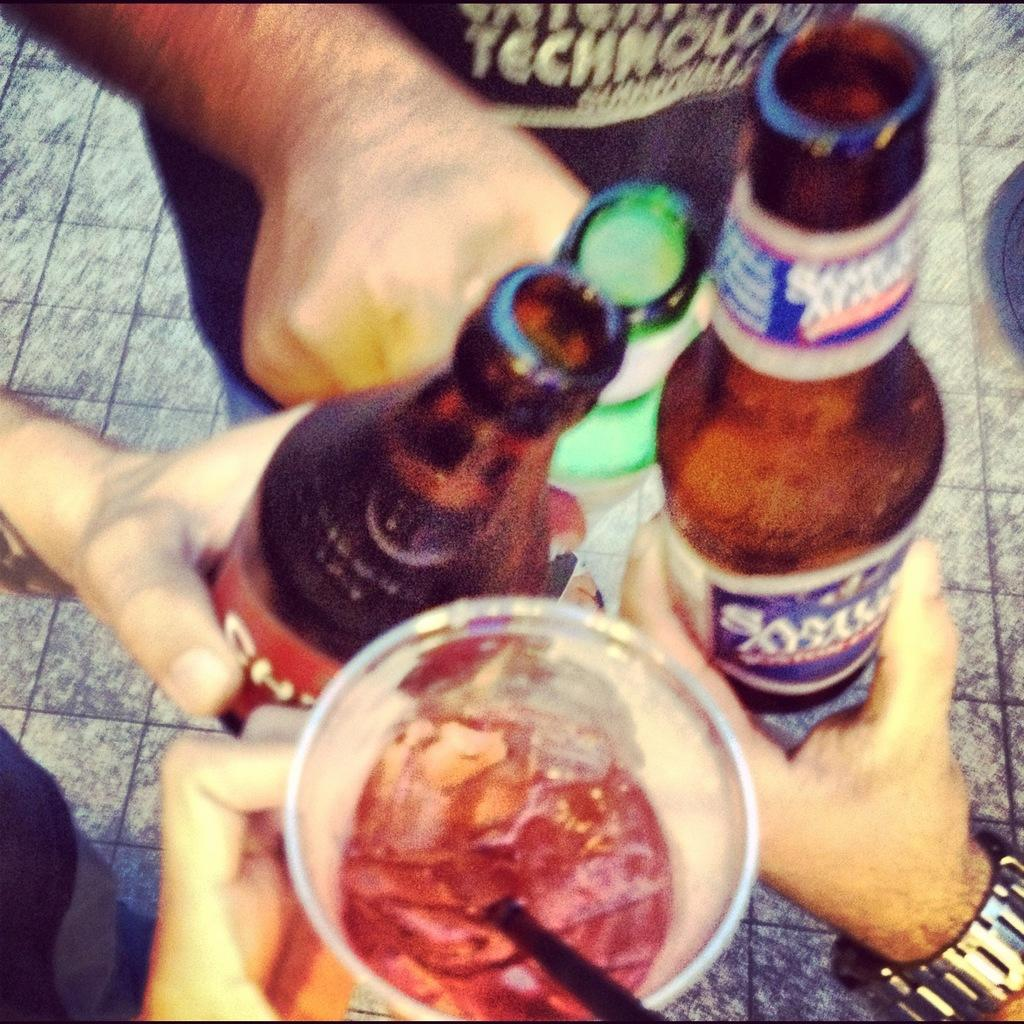How many people are present in the image? There are three people in the image. What are the people holding in the image? The people are holding a bottle. Are there any other bottles visible in the image? Yes, there are bottles in the image. What can be seen in the glass in the image? There is a glass with liquid content in the image. What might be used to drink the liquid in the glass? There is a straw in the image. What type of dress is the person wearing in the image? There is no mention of a dress in the image; the people are holding a bottle. Can you see any hoses in the image? There are no hoses present in the image. 